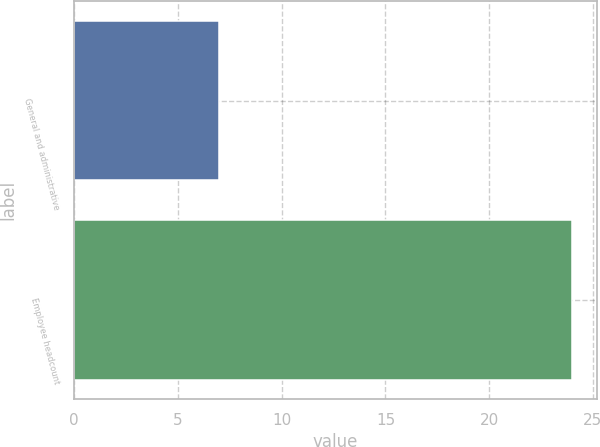Convert chart. <chart><loc_0><loc_0><loc_500><loc_500><bar_chart><fcel>General and administrative<fcel>Employee headcount<nl><fcel>7<fcel>24<nl></chart> 